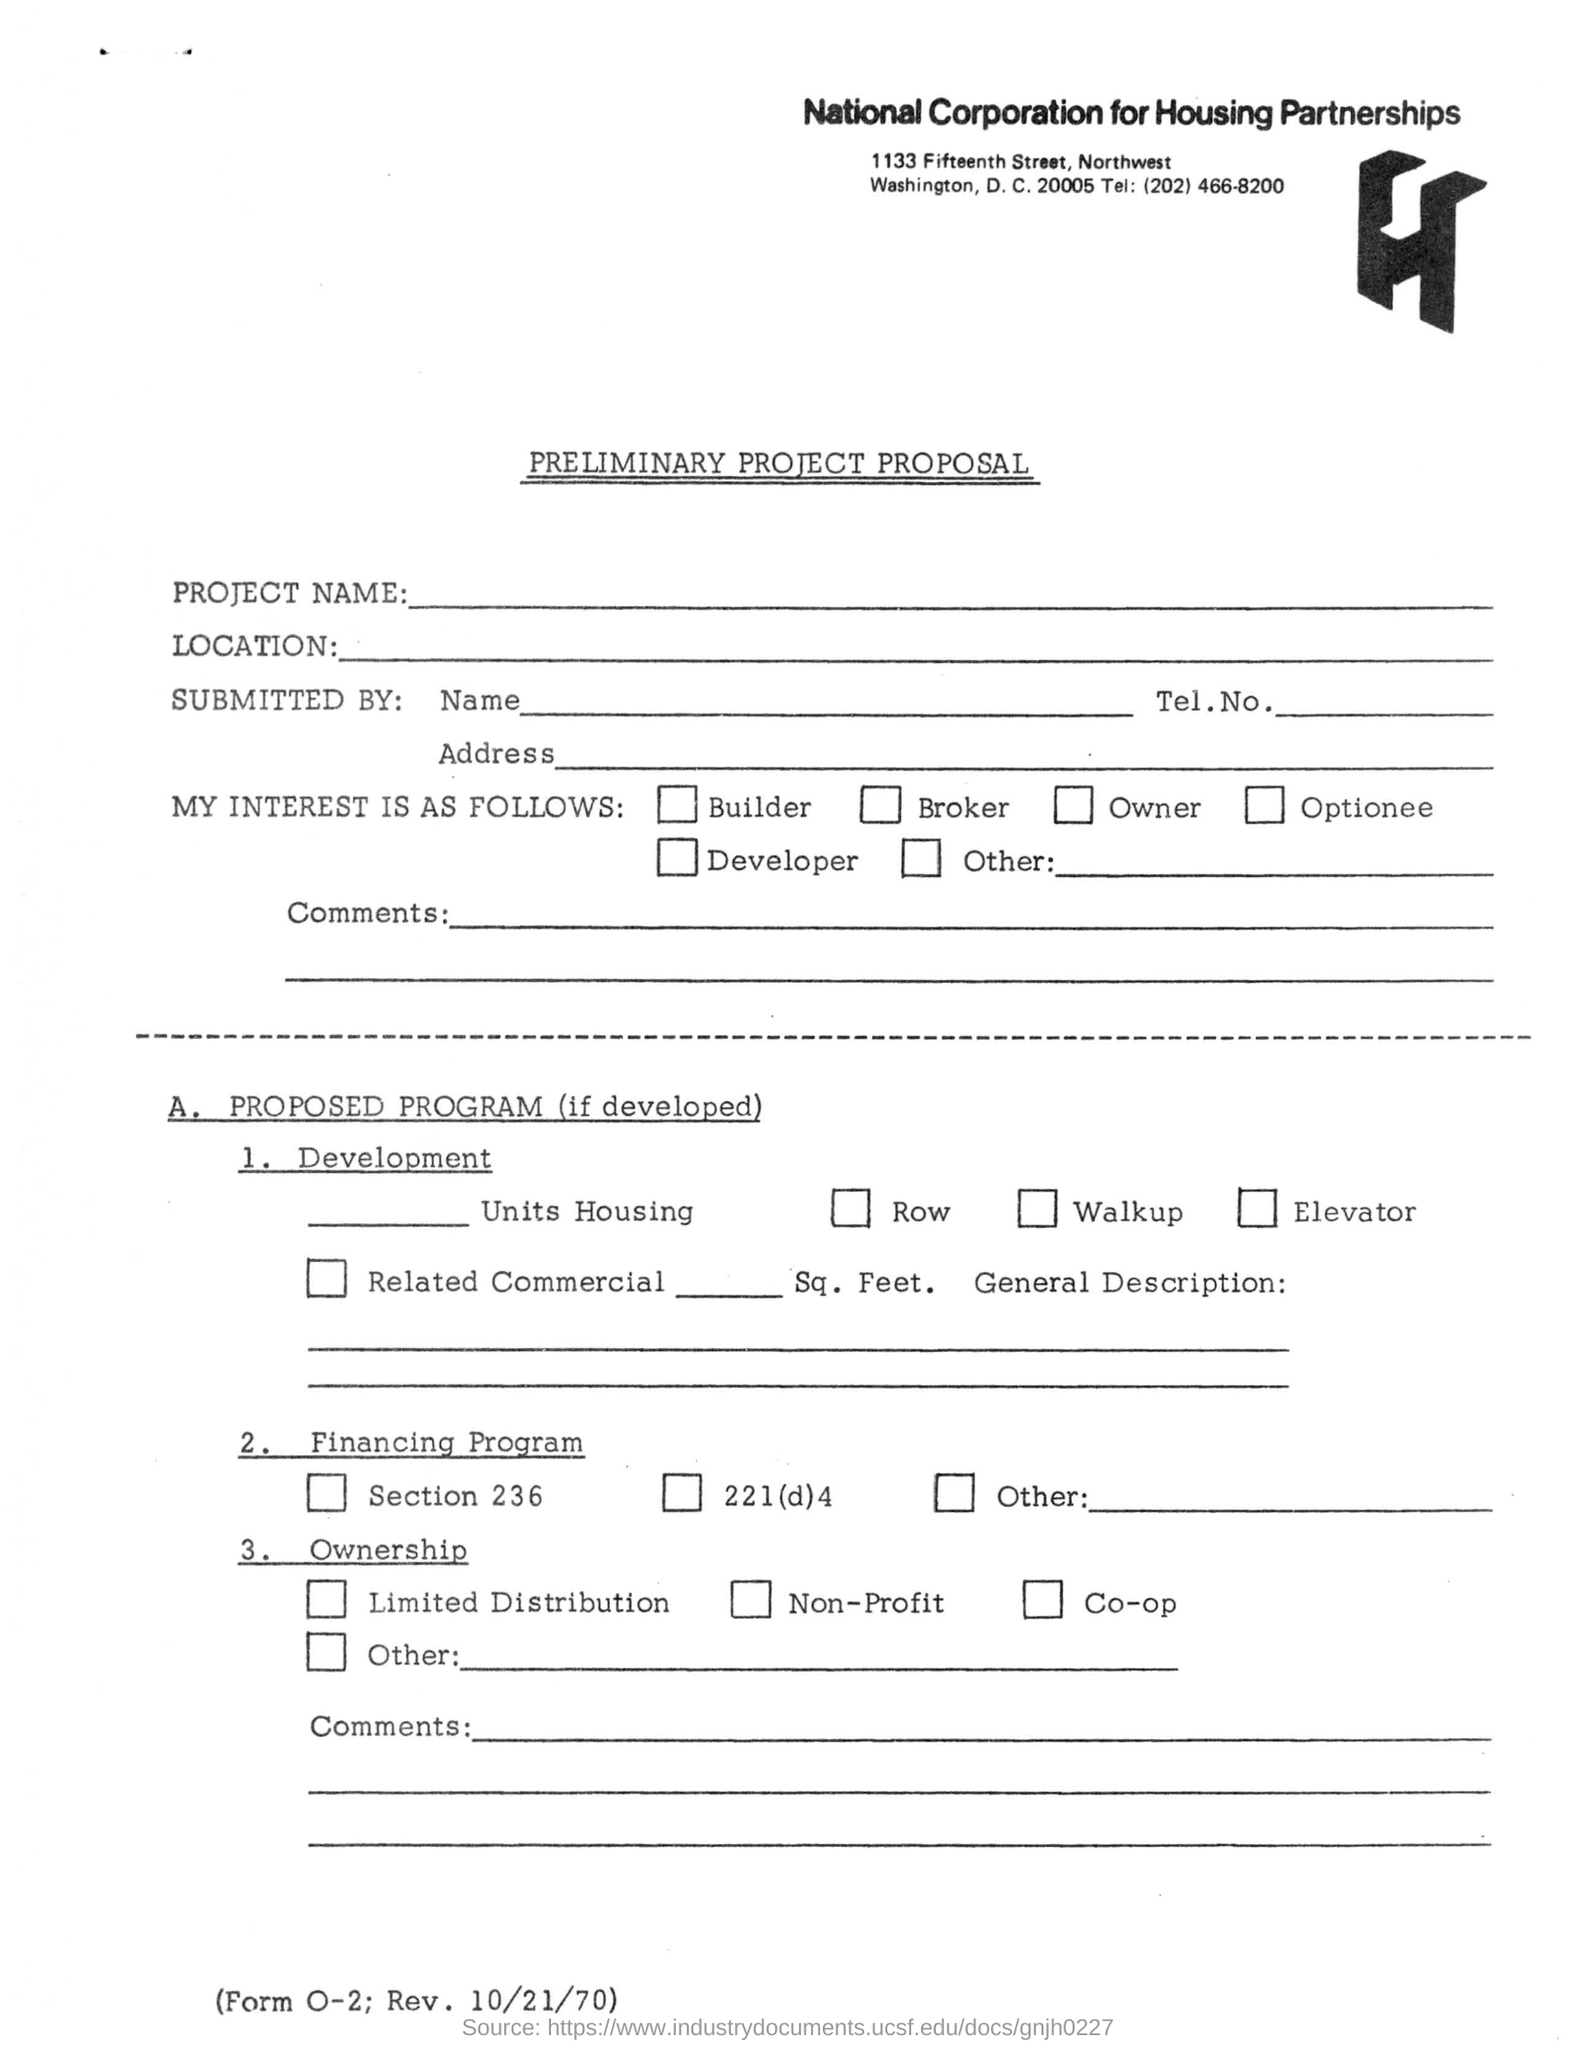Which organisation's document is this?
Give a very brief answer. National Corporation for Housing Partnerships. What form is this?
Provide a succinct answer. Preliminary Project Proposal. What is the telephone number given in the form?
Provide a succinct answer. (202) 466-8200. 